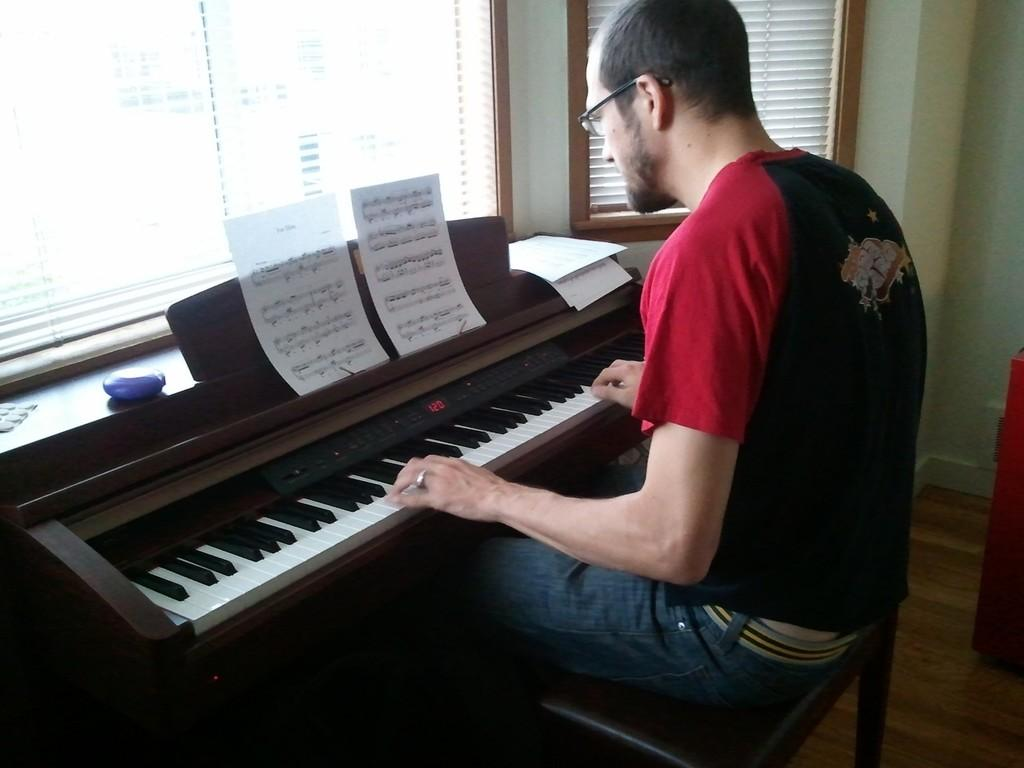Who is the person in the image? There is a man in the image. What is the man doing in the image? The man is sitting on a chair and playing a piano. Where is the scene taking place? The scene takes place inside a room. What type of question is the man asking in the image? There is no indication in the image that the man is asking a question. 